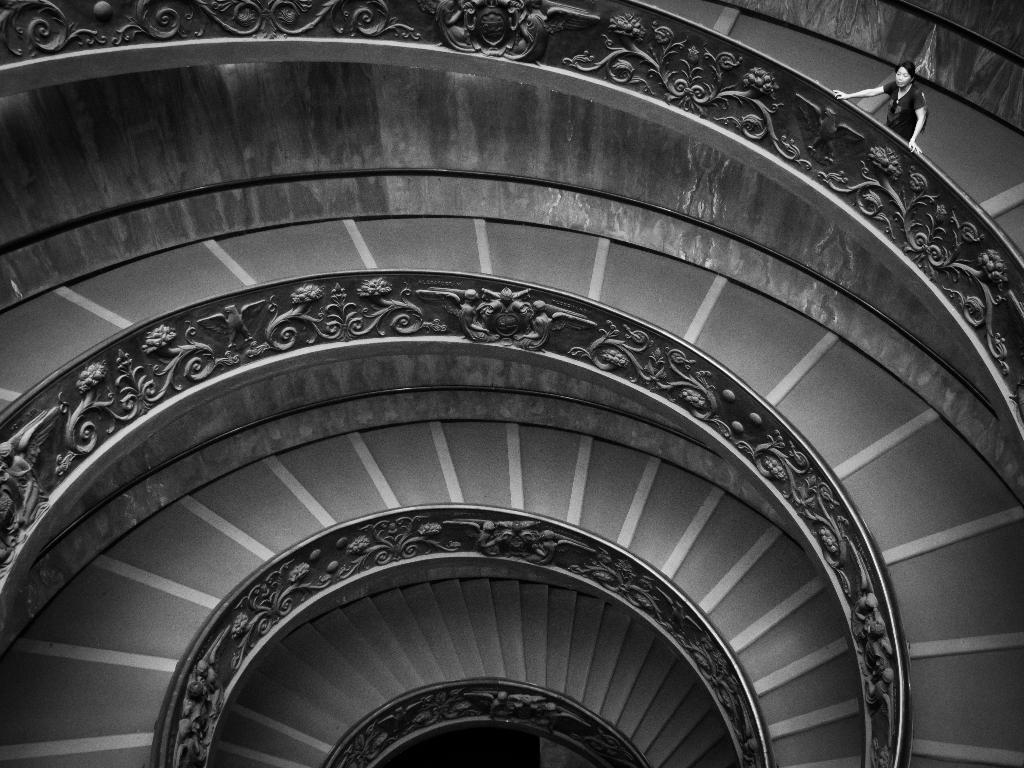How would you summarize this image in a sentence or two? This is a black and white pic. Here we can see a spiral staircase and on the right at the top corner there is a person standing on the steps and this is the wall. 